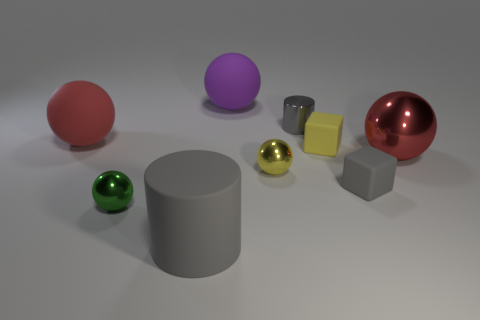There is a big matte thing that is the same color as the metal cylinder; what is its shape?
Provide a succinct answer. Cylinder. The tiny ball that is to the left of the purple rubber thing that is right of the tiny sphere on the left side of the rubber cylinder is made of what material?
Keep it short and to the point. Metal. There is a red metal thing that is the same size as the purple thing; what is its shape?
Your answer should be very brief. Sphere. Is there a tiny thing of the same color as the matte cylinder?
Keep it short and to the point. Yes. What size is the yellow ball?
Keep it short and to the point. Small. Do the large purple object and the tiny gray cube have the same material?
Your response must be concise. Yes. What number of tiny cylinders are on the left side of the yellow sphere that is left of the big red thing that is to the right of the big red matte thing?
Keep it short and to the point. 0. There is a gray object in front of the small green metal ball; what is its shape?
Make the answer very short. Cylinder. What number of other things are there of the same material as the yellow cube
Your answer should be compact. 4. Is the shiny cylinder the same color as the rubber cylinder?
Offer a terse response. Yes. 